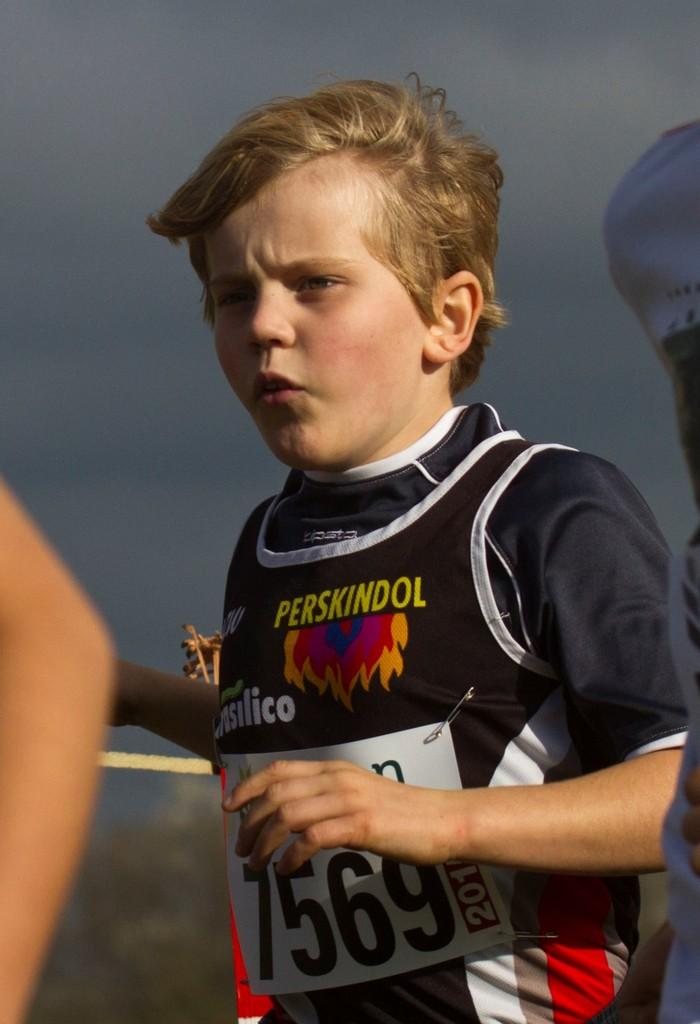<image>
Share a concise interpretation of the image provided. a kid with the numbers 7569 on their outfit 